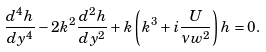Convert formula to latex. <formula><loc_0><loc_0><loc_500><loc_500>\frac { d ^ { 4 } h } { d y ^ { 4 } } - 2 k ^ { 2 } \frac { d ^ { 2 } h } { d y ^ { 2 } } + k \left ( k ^ { 3 } + i \frac { U } { \nu w ^ { 2 } } \right ) h = 0 .</formula> 